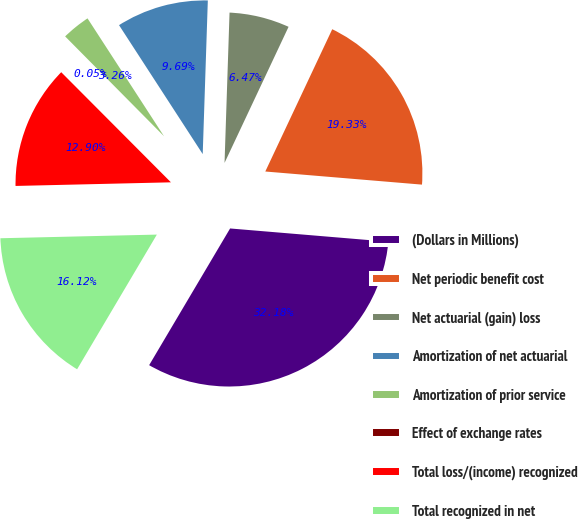<chart> <loc_0><loc_0><loc_500><loc_500><pie_chart><fcel>(Dollars in Millions)<fcel>Net periodic benefit cost<fcel>Net actuarial (gain) loss<fcel>Amortization of net actuarial<fcel>Amortization of prior service<fcel>Effect of exchange rates<fcel>Total loss/(income) recognized<fcel>Total recognized in net<nl><fcel>32.18%<fcel>19.33%<fcel>6.47%<fcel>9.69%<fcel>3.26%<fcel>0.05%<fcel>12.9%<fcel>16.12%<nl></chart> 